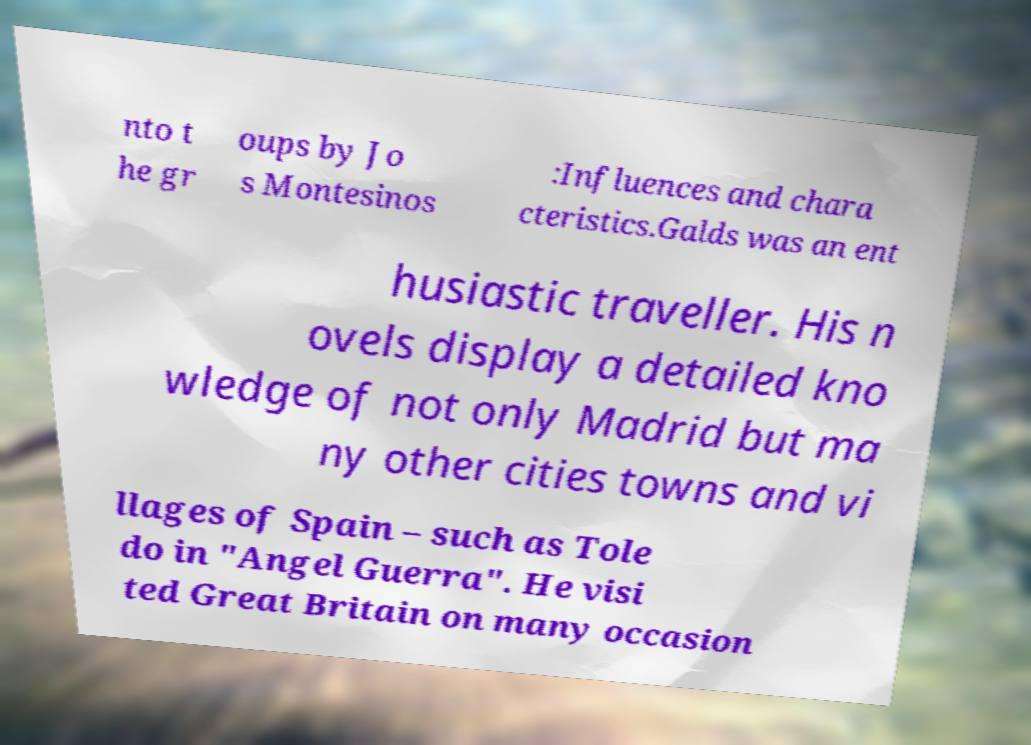There's text embedded in this image that I need extracted. Can you transcribe it verbatim? nto t he gr oups by Jo s Montesinos :Influences and chara cteristics.Galds was an ent husiastic traveller. His n ovels display a detailed kno wledge of not only Madrid but ma ny other cities towns and vi llages of Spain – such as Tole do in "Angel Guerra". He visi ted Great Britain on many occasion 